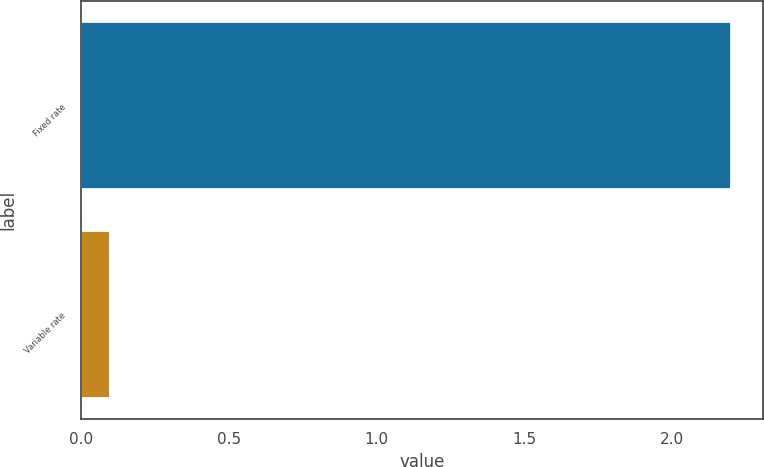<chart> <loc_0><loc_0><loc_500><loc_500><bar_chart><fcel>Fixed rate<fcel>Variable rate<nl><fcel>2.2<fcel>0.1<nl></chart> 